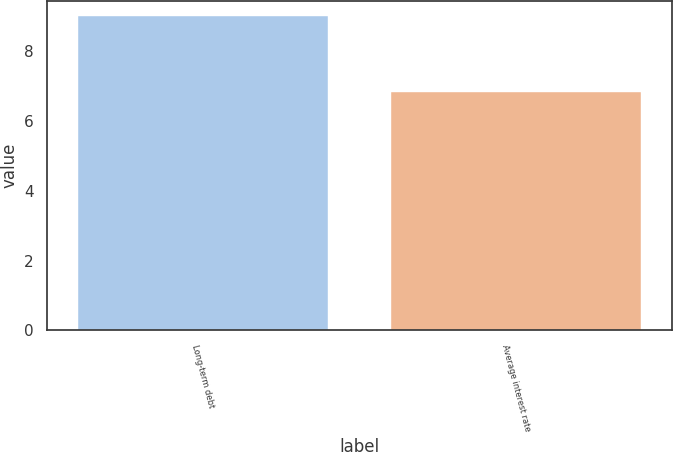<chart> <loc_0><loc_0><loc_500><loc_500><bar_chart><fcel>Long-term debt<fcel>Average interest rate<nl><fcel>9<fcel>6.84<nl></chart> 